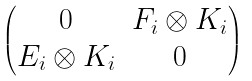<formula> <loc_0><loc_0><loc_500><loc_500>\begin{pmatrix} 0 & F _ { i } \otimes K _ { i } \\ E _ { i } \otimes K _ { i } & 0 \end{pmatrix}</formula> 